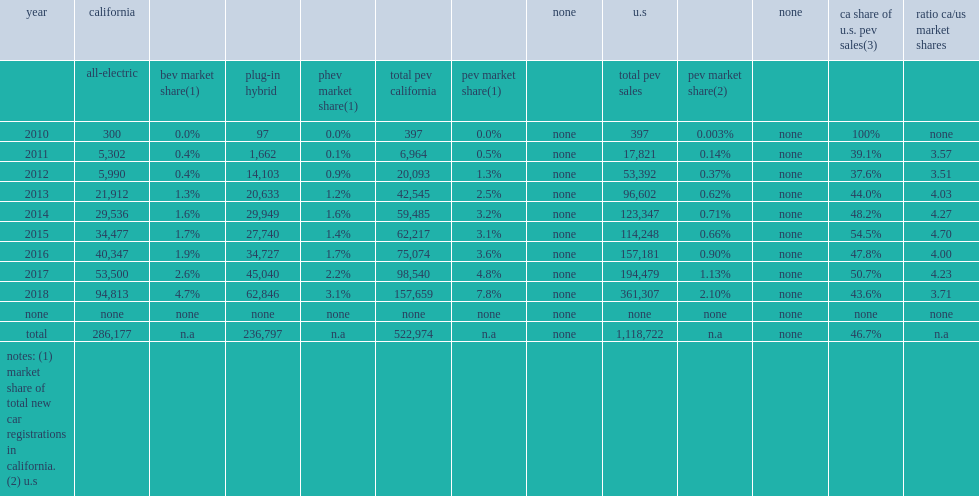How many times of california's market share are higher relative to the u.s. market in 2015? 4.7. 